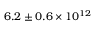Convert formula to latex. <formula><loc_0><loc_0><loc_500><loc_500>6 . 2 \pm 0 . 6 \times 1 0 ^ { 1 2 }</formula> 